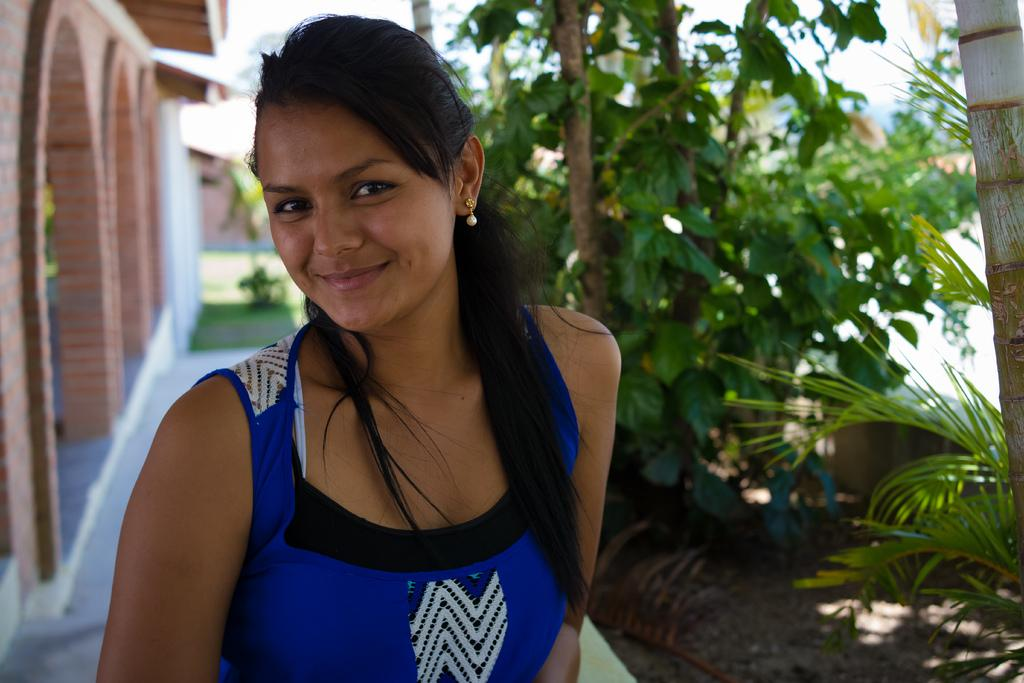Who is present in the image? There is a woman in the image. What is the woman's facial expression? The woman is smiling. What can be seen in the background of the image? There are buildings and trees in the background of the image. What type of shoe is the woman wearing in the image? There is no information about the woman's shoes in the image, so it cannot be determined from the image. 